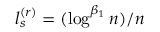<formula> <loc_0><loc_0><loc_500><loc_500>l _ { s } ^ { ( r ) } = ( \log ^ { \beta _ { 1 } } n ) / n</formula> 